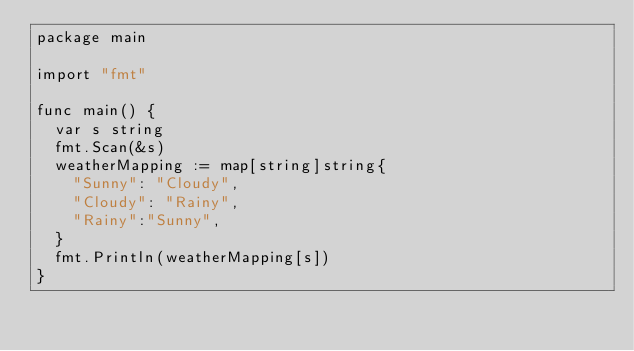<code> <loc_0><loc_0><loc_500><loc_500><_Go_>package main

import "fmt"

func main() {
	var s string
	fmt.Scan(&s)
	weatherMapping := map[string]string{
		"Sunny": "Cloudy",
		"Cloudy": "Rainy",
		"Rainy":"Sunny",
	}
	fmt.Println(weatherMapping[s])
}</code> 